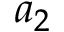<formula> <loc_0><loc_0><loc_500><loc_500>a _ { 2 }</formula> 